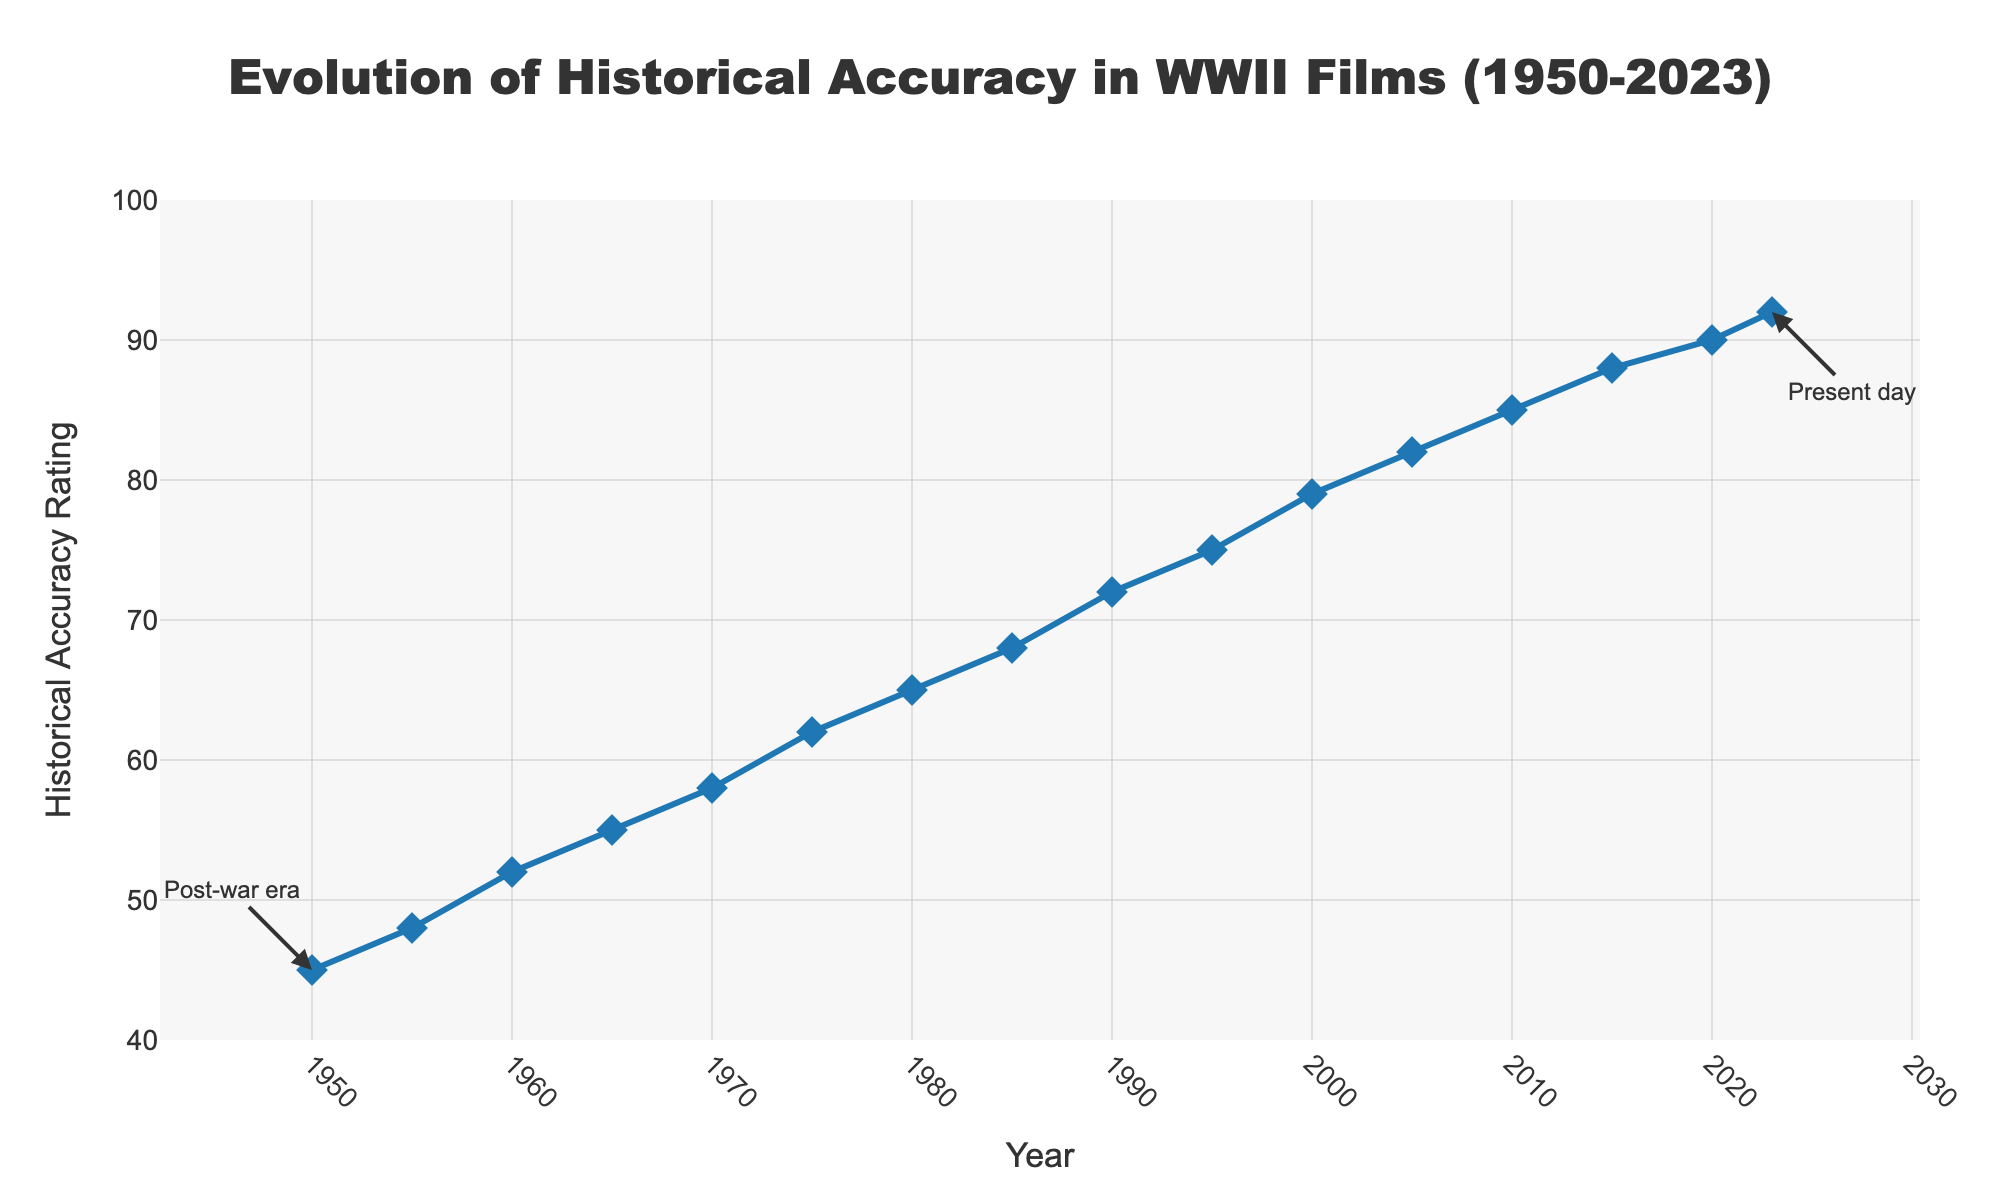What is the historical accuracy rating of WWII films in the year 1970? Locate the year 1970 on the x-axis and observe the corresponding value on the y-axis. The historical accuracy rating is 58.
Answer: 58 How much did the historical accuracy rating increase between 1950 and 2000? Subtract the historical accuracy rating in 1950 (45) from the rating in 2000 (79): 79 - 45
Answer: 34 Which decade saw the highest increase in the historical accuracy rating, and what was the increase? Calculate the rating increases for each decade. For example, from 1950 to 1960: 52 - 45 = 7, from 1960 to 1970: 58 - 52 = 6, etc. The decade with the highest increase is 1990 to 2000: 79 - 72 = 7.
Answer: 1990s, 7 By how much did the historical accuracy rating change between 1980 and 1990, and was it an increase or decrease? Find the ratings for 1980 (65) and 1990 (72). Calculate the difference: 72 - 65 = 7. The rating increased.
Answer: Increase by 7 What is the average historical accuracy rating in the 21st century so far (2000-2023)? Sum the ratings from 2000 (79), 2005 (82), 2010 (85), 2015 (88), 2020 (90), and 2023 (92). Then divide by the number of data points (6): (79 + 82 + 85 + 88 + 90 + 92) / 6
Answer: 86 Compare the historical accuracy of WWII films in 1955 and 2005. Which year had a higher rating? Compare the ratings of 1955 (48) and 2005 (82). The year 2005 had a higher rating.
Answer: 2005 When did the historical accuracy rating first surpass 80? Find the first year where the rating exceeded 80. The rating surpassed 80 in 2005.
Answer: 2005 How did the historical accuracy rating trend from 1985 to 2000? Observe the values from 1985 (68) to 2000 (79). The rating consistently increased over this period.
Answer: Increased What are the color and symbol used for the data points in the plot? The data points are marked with blue diamond symbols.
Answer: Blue diamond What annotation is associated with the year 1950 on the plot? The annotation for 1950 on the plot highlights the "Post-war era."
Answer: Post-war era 